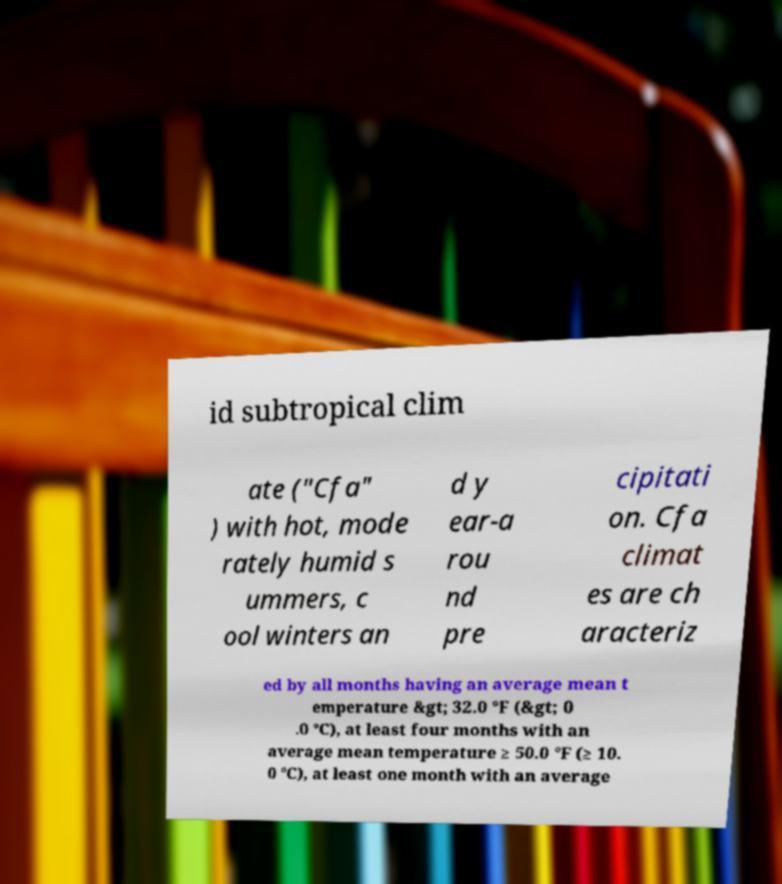I need the written content from this picture converted into text. Can you do that? id subtropical clim ate ("Cfa" ) with hot, mode rately humid s ummers, c ool winters an d y ear-a rou nd pre cipitati on. Cfa climat es are ch aracteriz ed by all months having an average mean t emperature &gt; 32.0 °F (&gt; 0 .0 °C), at least four months with an average mean temperature ≥ 50.0 °F (≥ 10. 0 °C), at least one month with an average 